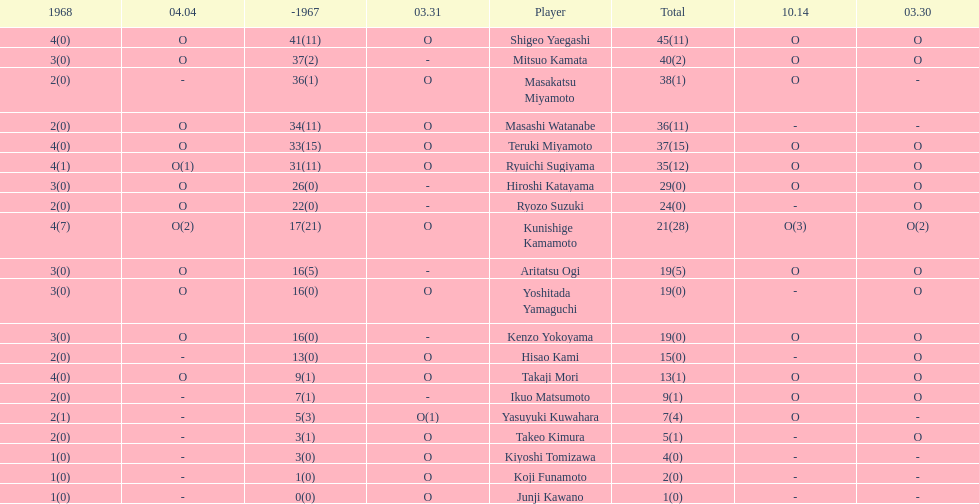How many points did takaji mori have? 13(1). And how many points did junji kawano have? 1(0). To who does the higher of these belong to? Takaji Mori. 